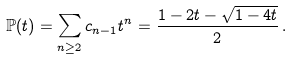<formula> <loc_0><loc_0><loc_500><loc_500>\mathbb { P } ( t ) = \sum _ { n \geq 2 } c _ { n - 1 } t ^ { n } = \frac { 1 - 2 t - \sqrt { 1 - 4 t } } { 2 } \, .</formula> 